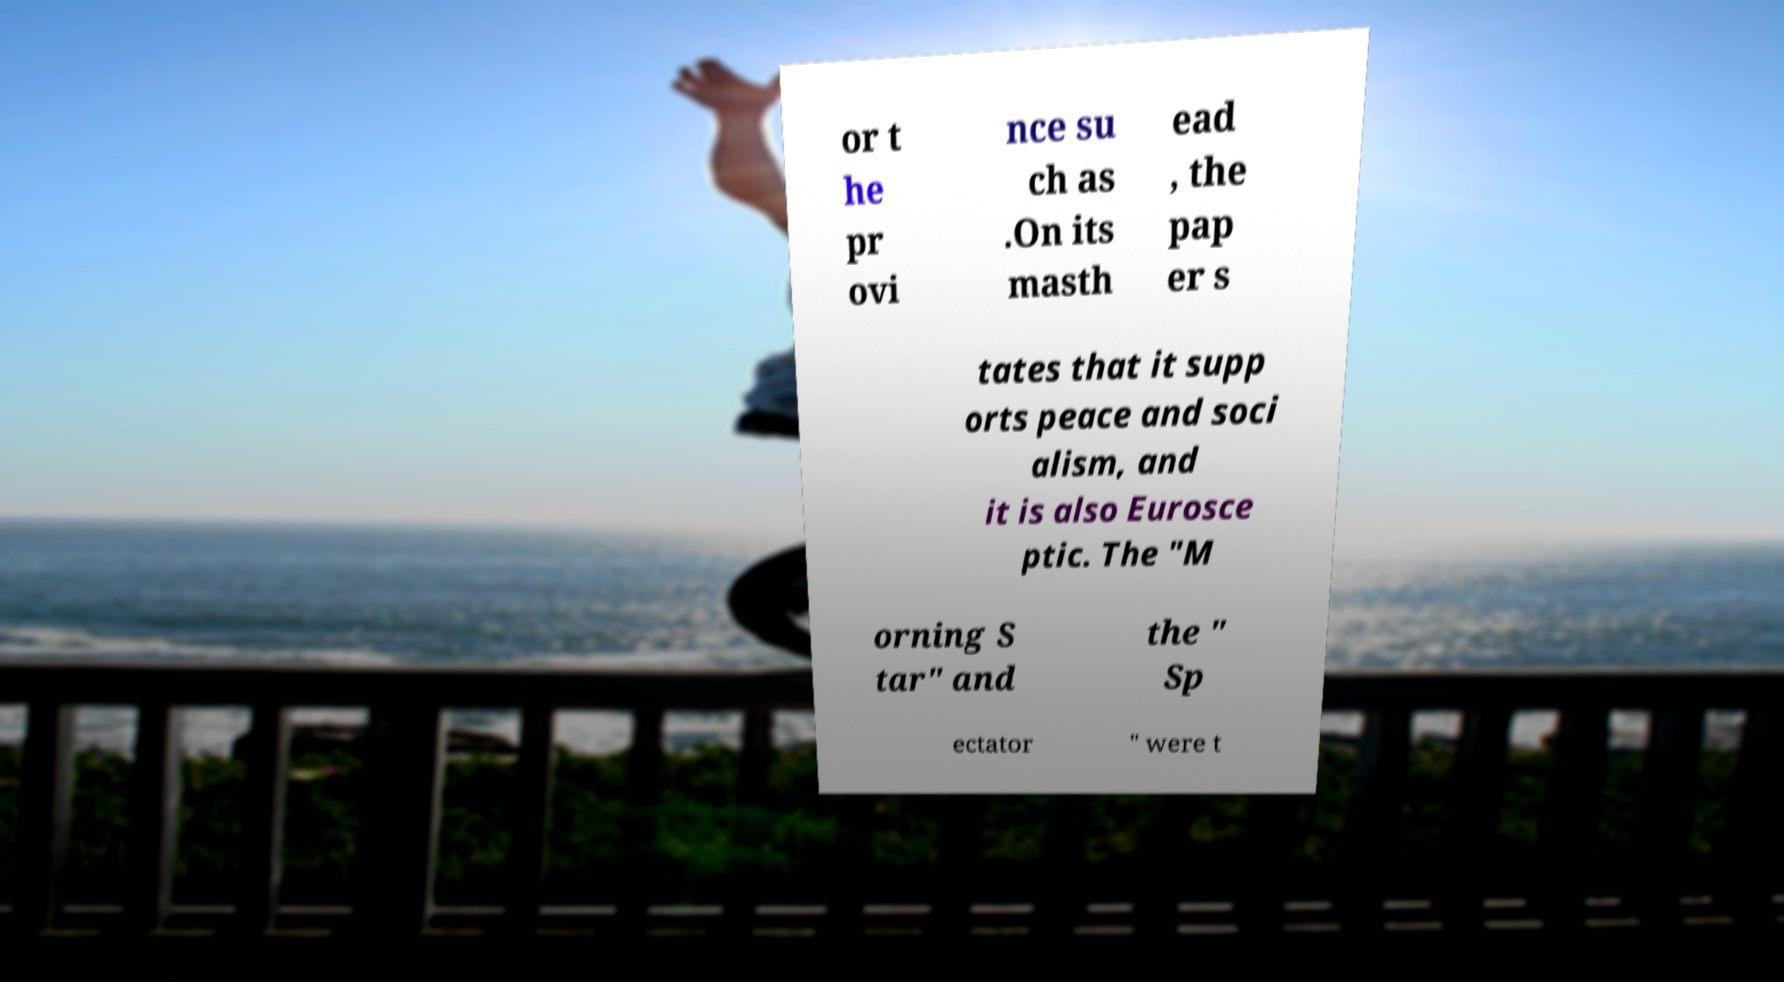Can you accurately transcribe the text from the provided image for me? or t he pr ovi nce su ch as .On its masth ead , the pap er s tates that it supp orts peace and soci alism, and it is also Eurosce ptic. The "M orning S tar" and the " Sp ectator " were t 